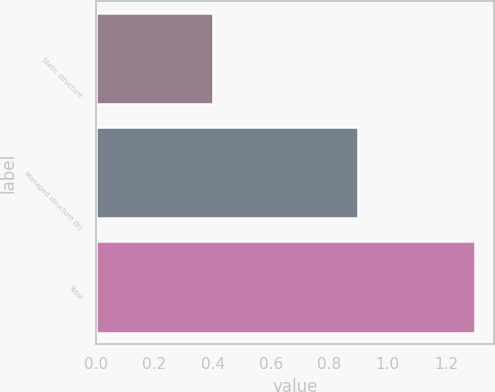Convert chart. <chart><loc_0><loc_0><loc_500><loc_500><bar_chart><fcel>Static structure<fcel>Managed structure (b)<fcel>Total<nl><fcel>0.4<fcel>0.9<fcel>1.3<nl></chart> 